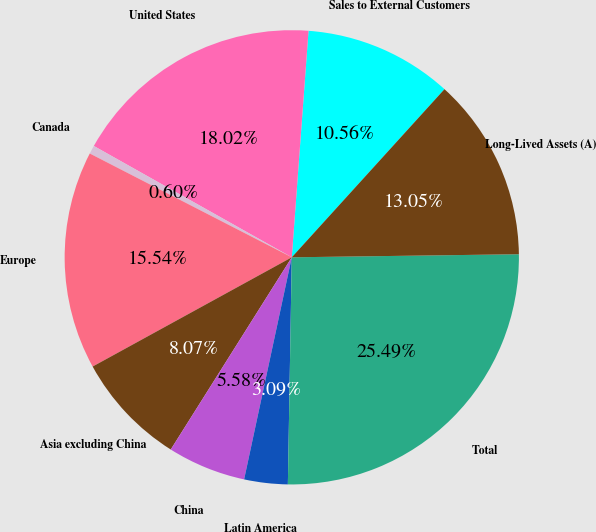<chart> <loc_0><loc_0><loc_500><loc_500><pie_chart><fcel>Sales to External Customers<fcel>United States<fcel>Canada<fcel>Europe<fcel>Asia excluding China<fcel>China<fcel>Latin America<fcel>Total<fcel>Long-Lived Assets (A)<nl><fcel>10.56%<fcel>18.02%<fcel>0.6%<fcel>15.54%<fcel>8.07%<fcel>5.58%<fcel>3.09%<fcel>25.49%<fcel>13.05%<nl></chart> 